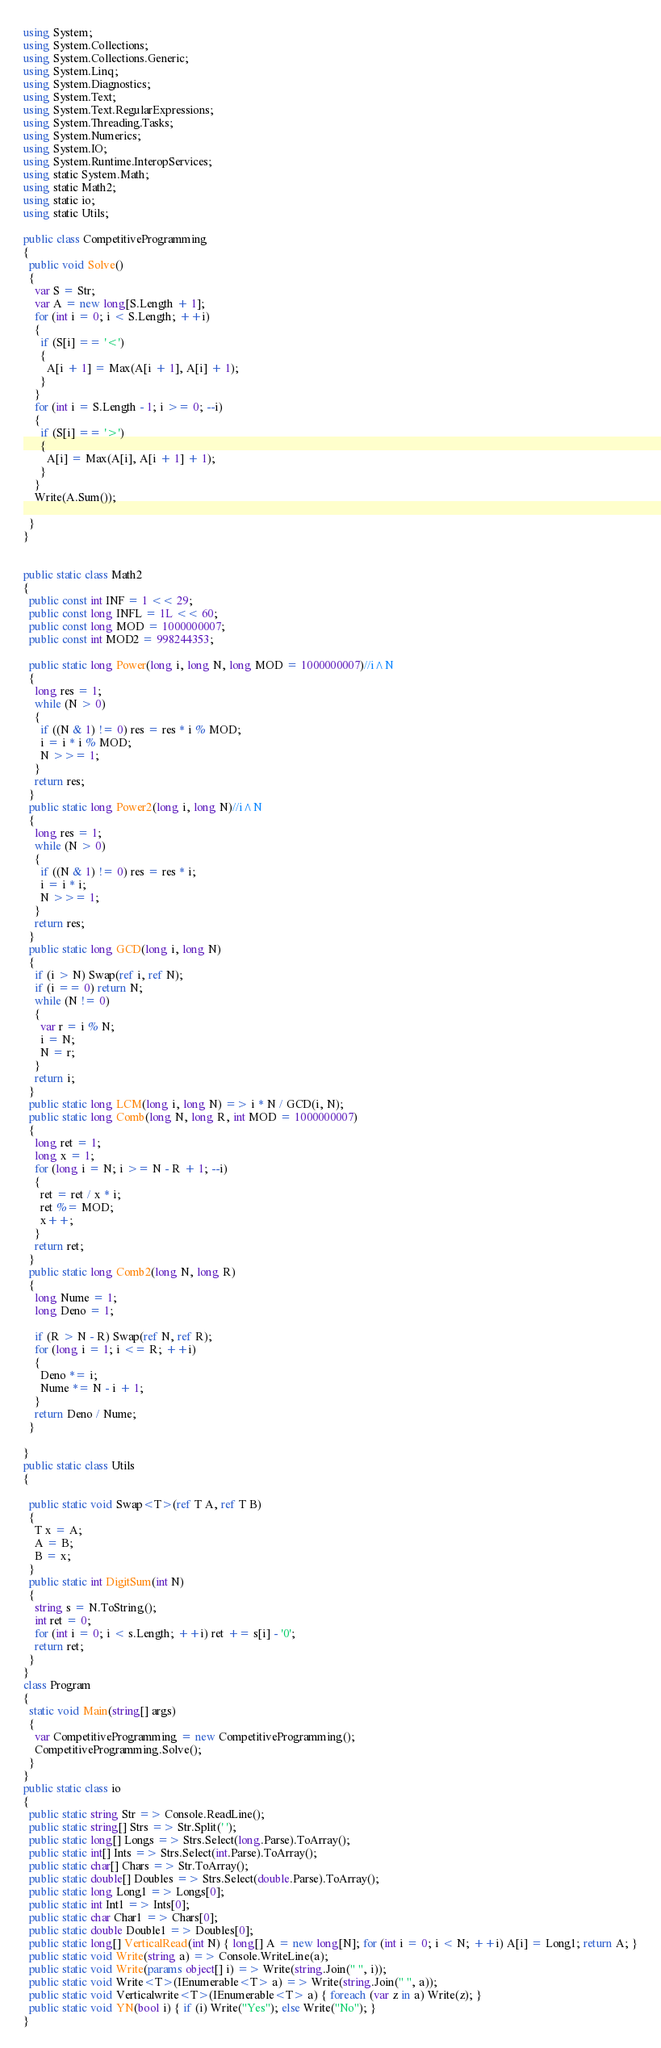<code> <loc_0><loc_0><loc_500><loc_500><_C#_>using System;
using System.Collections;
using System.Collections.Generic;
using System.Linq;
using System.Diagnostics;
using System.Text;
using System.Text.RegularExpressions;
using System.Threading.Tasks;
using System.Numerics;
using System.IO;
using System.Runtime.InteropServices;
using static System.Math;
using static Math2;
using static io;
using static Utils;

public class CompetitiveProgramming
{
  public void Solve()
  {
    var S = Str;
    var A = new long[S.Length + 1];
    for (int i = 0; i < S.Length; ++i)
    {
      if (S[i] == '<')
      {
        A[i + 1] = Max(A[i + 1], A[i] + 1);
      }
    }
    for (int i = S.Length - 1; i >= 0; --i)
    {
      if (S[i] == '>')
      {
        A[i] = Max(A[i], A[i + 1] + 1);
      }
    }
    Write(A.Sum());

  }
}


public static class Math2
{
  public const int INF = 1 << 29;
  public const long INFL = 1L << 60;
  public const long MOD = 1000000007;
  public const int MOD2 = 998244353;

  public static long Power(long i, long N, long MOD = 1000000007)//i^N
  {
    long res = 1;
    while (N > 0)
    {
      if ((N & 1) != 0) res = res * i % MOD;
      i = i * i % MOD;
      N >>= 1;
    }
    return res;
  }
  public static long Power2(long i, long N)//i^N
  {
    long res = 1;
    while (N > 0)
    {
      if ((N & 1) != 0) res = res * i;
      i = i * i;
      N >>= 1;
    }
    return res;
  }
  public static long GCD(long i, long N)
  {
    if (i > N) Swap(ref i, ref N);
    if (i == 0) return N;
    while (N != 0)
    {
      var r = i % N;
      i = N;
      N = r;
    }
    return i;
  }
  public static long LCM(long i, long N) => i * N / GCD(i, N);
  public static long Comb(long N, long R, int MOD = 1000000007)
  {
    long ret = 1;
    long x = 1;
    for (long i = N; i >= N - R + 1; --i)
    {
      ret = ret / x * i;
      ret %= MOD;
      x++;
    }
    return ret;
  }
  public static long Comb2(long N, long R)
  {
    long Nume = 1;
    long Deno = 1;

    if (R > N - R) Swap(ref N, ref R);
    for (long i = 1; i <= R; ++i)
    {
      Deno *= i;
      Nume *= N - i + 1;
    }
    return Deno / Nume;
  }

}
public static class Utils
{

  public static void Swap<T>(ref T A, ref T B)
  {
    T x = A;
    A = B;
    B = x;
  }
  public static int DigitSum(int N)
  {
    string s = N.ToString();
    int ret = 0;
    for (int i = 0; i < s.Length; ++i) ret += s[i] - '0';
    return ret;
  }
}
class Program
{
  static void Main(string[] args)
  {
    var CompetitiveProgramming = new CompetitiveProgramming();
    CompetitiveProgramming.Solve();
  }
}
public static class io
{
  public static string Str => Console.ReadLine();
  public static string[] Strs => Str.Split(' ');
  public static long[] Longs => Strs.Select(long.Parse).ToArray();
  public static int[] Ints => Strs.Select(int.Parse).ToArray();
  public static char[] Chars => Str.ToArray();
  public static double[] Doubles => Strs.Select(double.Parse).ToArray();
  public static long Long1 => Longs[0];
  public static int Int1 => Ints[0];
  public static char Char1 => Chars[0];
  public static double Double1 => Doubles[0];
  public static long[] VerticalRead(int N) { long[] A = new long[N]; for (int i = 0; i < N; ++i) A[i] = Long1; return A; }
  public static void Write(string a) => Console.WriteLine(a);
  public static void Write(params object[] i) => Write(string.Join(" ", i));
  public static void Write<T>(IEnumerable<T> a) => Write(string.Join(" ", a));
  public static void Verticalwrite<T>(IEnumerable<T> a) { foreach (var z in a) Write(z); }
  public static void YN(bool i) { if (i) Write("Yes"); else Write("No"); }
}
</code> 